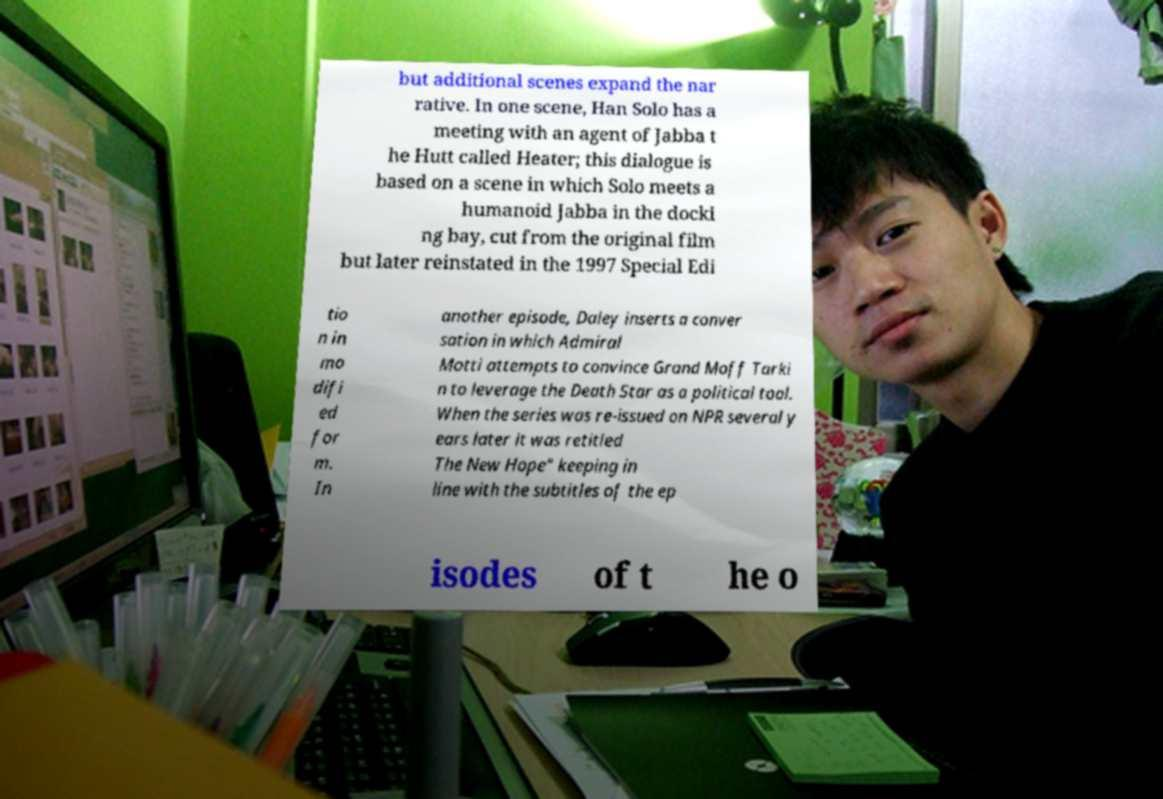Please read and relay the text visible in this image. What does it say? but additional scenes expand the nar rative. In one scene, Han Solo has a meeting with an agent of Jabba t he Hutt called Heater; this dialogue is based on a scene in which Solo meets a humanoid Jabba in the docki ng bay, cut from the original film but later reinstated in the 1997 Special Edi tio n in mo difi ed for m. In another episode, Daley inserts a conver sation in which Admiral Motti attempts to convince Grand Moff Tarki n to leverage the Death Star as a political tool. When the series was re-issued on NPR several y ears later it was retitled The New Hope" keeping in line with the subtitles of the ep isodes of t he o 